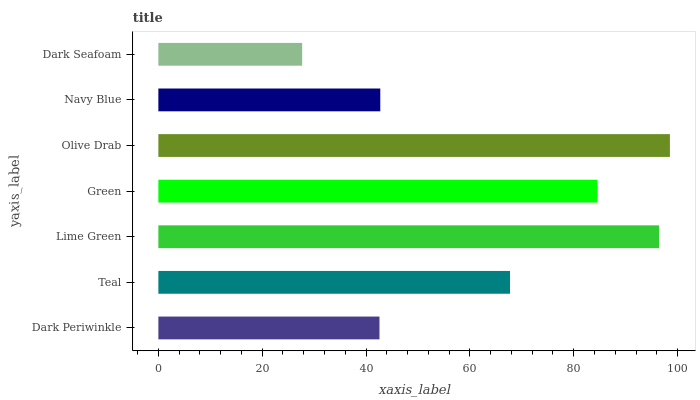Is Dark Seafoam the minimum?
Answer yes or no. Yes. Is Olive Drab the maximum?
Answer yes or no. Yes. Is Teal the minimum?
Answer yes or no. No. Is Teal the maximum?
Answer yes or no. No. Is Teal greater than Dark Periwinkle?
Answer yes or no. Yes. Is Dark Periwinkle less than Teal?
Answer yes or no. Yes. Is Dark Periwinkle greater than Teal?
Answer yes or no. No. Is Teal less than Dark Periwinkle?
Answer yes or no. No. Is Teal the high median?
Answer yes or no. Yes. Is Teal the low median?
Answer yes or no. Yes. Is Dark Seafoam the high median?
Answer yes or no. No. Is Olive Drab the low median?
Answer yes or no. No. 